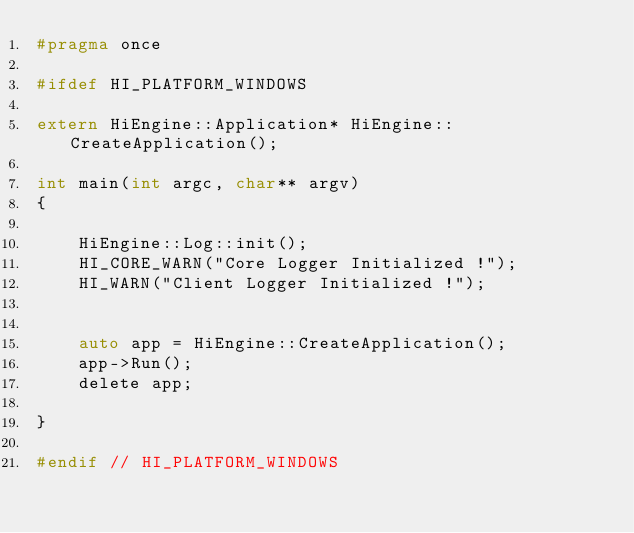<code> <loc_0><loc_0><loc_500><loc_500><_C_>#pragma once

#ifdef HI_PLATFORM_WINDOWS

extern HiEngine::Application* HiEngine::CreateApplication();

int main(int argc, char** argv)
{

	HiEngine::Log::init();
	HI_CORE_WARN("Core Logger Initialized !");
	HI_WARN("Client Logger Initialized !");


	auto app = HiEngine::CreateApplication();
	app->Run();
	delete app;

}

#endif // HI_PLATFORM_WINDOWS
</code> 